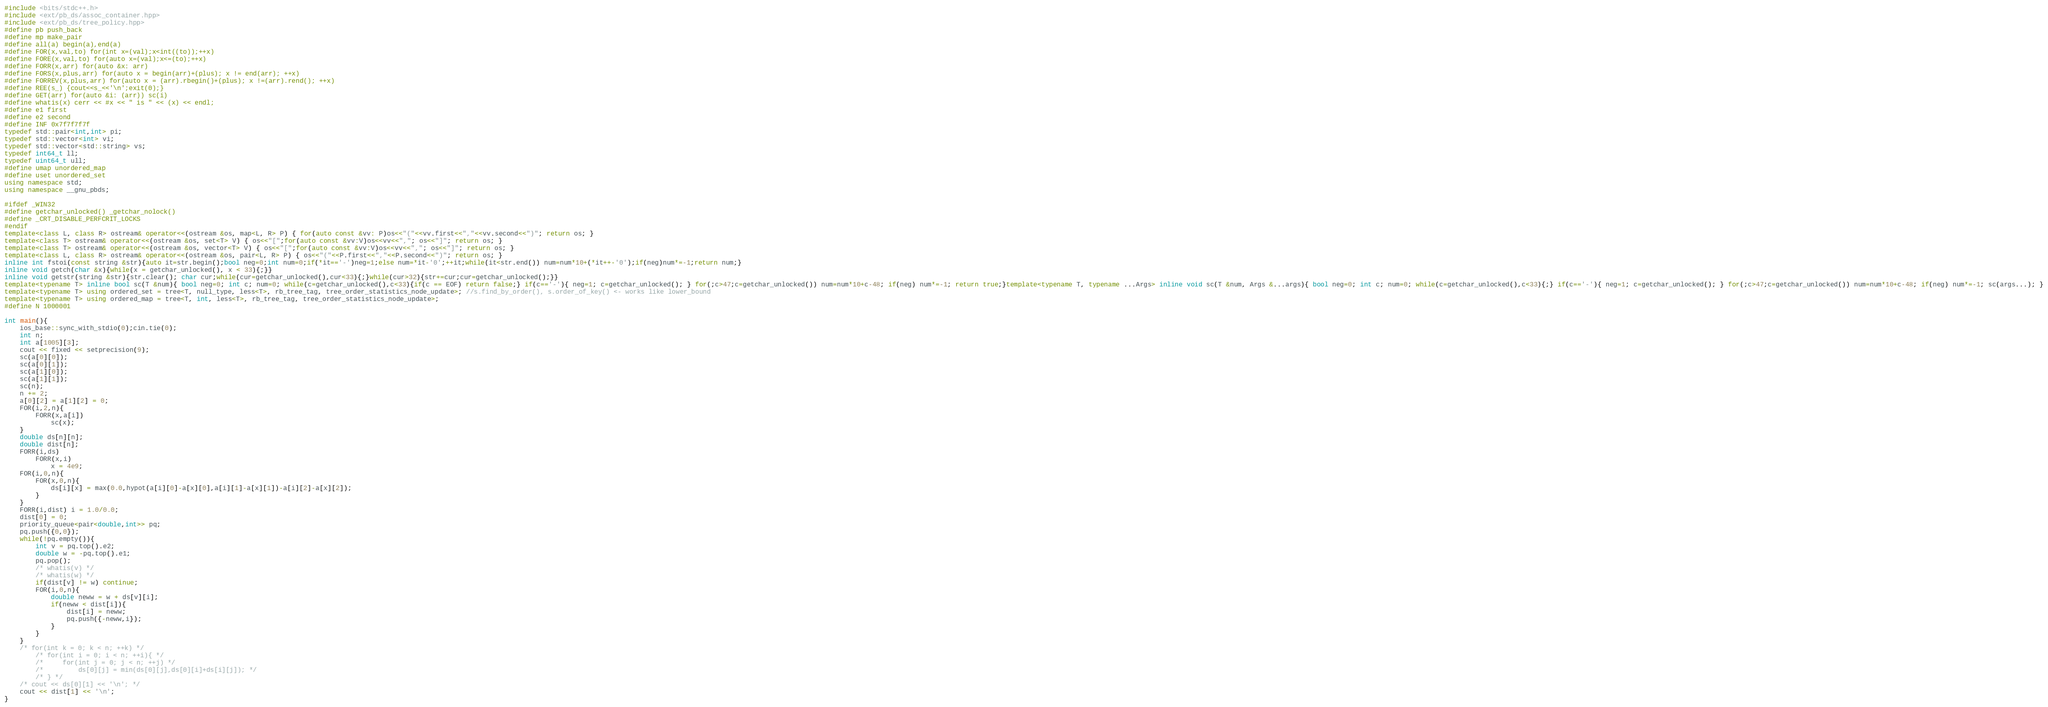Convert code to text. <code><loc_0><loc_0><loc_500><loc_500><_C++_>#include <bits/stdc++.h>
#include <ext/pb_ds/assoc_container.hpp>
#include <ext/pb_ds/tree_policy.hpp>
#define pb push_back
#define mp make_pair
#define all(a) begin(a),end(a)
#define FOR(x,val,to) for(int x=(val);x<int((to));++x)
#define FORE(x,val,to) for(auto x=(val);x<=(to);++x)
#define FORR(x,arr) for(auto &x: arr)
#define FORS(x,plus,arr) for(auto x = begin(arr)+(plus); x != end(arr); ++x)
#define FORREV(x,plus,arr) for(auto x = (arr).rbegin()+(plus); x !=(arr).rend(); ++x)
#define REE(s_) {cout<<s_<<'\n';exit(0);}
#define GET(arr) for(auto &i: (arr)) sc(i)
#define whatis(x) cerr << #x << " is " << (x) << endl;
#define e1 first
#define e2 second
#define INF 0x7f7f7f7f
typedef std::pair<int,int> pi;
typedef std::vector<int> vi;
typedef std::vector<std::string> vs;
typedef int64_t ll;
typedef uint64_t ull;
#define umap unordered_map
#define uset unordered_set
using namespace std;
using namespace __gnu_pbds;

#ifdef _WIN32
#define getchar_unlocked() _getchar_nolock()
#define _CRT_DISABLE_PERFCRIT_LOCKS
#endif
template<class L, class R> ostream& operator<<(ostream &os, map<L, R> P) { for(auto const &vv: P)os<<"("<<vv.first<<","<<vv.second<<")"; return os; }
template<class T> ostream& operator<<(ostream &os, set<T> V) { os<<"[";for(auto const &vv:V)os<<vv<<","; os<<"]"; return os; }
template<class T> ostream& operator<<(ostream &os, vector<T> V) { os<<"[";for(auto const &vv:V)os<<vv<<","; os<<"]"; return os; }
template<class L, class R> ostream& operator<<(ostream &os, pair<L, R> P) { os<<"("<<P.first<<","<<P.second<<")"; return os; }
inline int fstoi(const string &str){auto it=str.begin();bool neg=0;int num=0;if(*it=='-')neg=1;else num=*it-'0';++it;while(it<str.end()) num=num*10+(*it++-'0');if(neg)num*=-1;return num;}
inline void getch(char &x){while(x = getchar_unlocked(), x < 33){;}}
inline void getstr(string &str){str.clear(); char cur;while(cur=getchar_unlocked(),cur<33){;}while(cur>32){str+=cur;cur=getchar_unlocked();}}
template<typename T> inline bool sc(T &num){ bool neg=0; int c; num=0; while(c=getchar_unlocked(),c<33){if(c == EOF) return false;} if(c=='-'){ neg=1; c=getchar_unlocked(); } for(;c>47;c=getchar_unlocked()) num=num*10+c-48; if(neg) num*=-1; return true;}template<typename T, typename ...Args> inline void sc(T &num, Args &...args){ bool neg=0; int c; num=0; while(c=getchar_unlocked(),c<33){;} if(c=='-'){ neg=1; c=getchar_unlocked(); } for(;c>47;c=getchar_unlocked()) num=num*10+c-48; if(neg) num*=-1; sc(args...); }
template<typename T> using ordered_set = tree<T, null_type, less<T>, rb_tree_tag, tree_order_statistics_node_update>; //s.find_by_order(), s.order_of_key() <- works like lower_bound
template<typename T> using ordered_map = tree<T, int, less<T>, rb_tree_tag, tree_order_statistics_node_update>;
#define N 1000001

int main(){
    ios_base::sync_with_stdio(0);cin.tie(0);
    int n;
    int a[1005][3];
    cout << fixed << setprecision(9);
    sc(a[0][0]);
    sc(a[0][1]);
    sc(a[1][0]);
    sc(a[1][1]);
    sc(n);
    n += 2;
    a[0][2] = a[1][2] = 0;
    FOR(i,2,n){
        FORR(x,a[i])
            sc(x);
    }
    double ds[n][n];
    double dist[n];
    FORR(i,ds)
        FORR(x,i)
            x = 4e9;
    FOR(i,0,n){
        FOR(x,0,n){
            ds[i][x] = max(0.0,hypot(a[i][0]-a[x][0],a[i][1]-a[x][1])-a[i][2]-a[x][2]);
        }
    }
    FORR(i,dist) i = 1.0/0.0;
    dist[0] = 0;
    priority_queue<pair<double,int>> pq;
    pq.push({0,0});
    while(!pq.empty()){
        int v = pq.top().e2;
        double w = -pq.top().e1;
        pq.pop();
        /* whatis(v) */
        /* whatis(w) */
        if(dist[v] != w) continue;
        FOR(i,0,n){
            double neww = w + ds[v][i];
            if(neww < dist[i]){
                dist[i] = neww;
                pq.push({-neww,i});
            }
        }
    }
    /* for(int k = 0; k < n; ++k) */
        /* for(int i = 0; i < n; ++i){ */
        /*     for(int j = 0; j < n; ++j) */
        /*         ds[0][j] = min(ds[0][j],ds[0][i]+ds[i][j]); */
        /* } */
    /* cout << ds[0][1] << '\n'; */
    cout << dist[1] << '\n';
}

</code> 